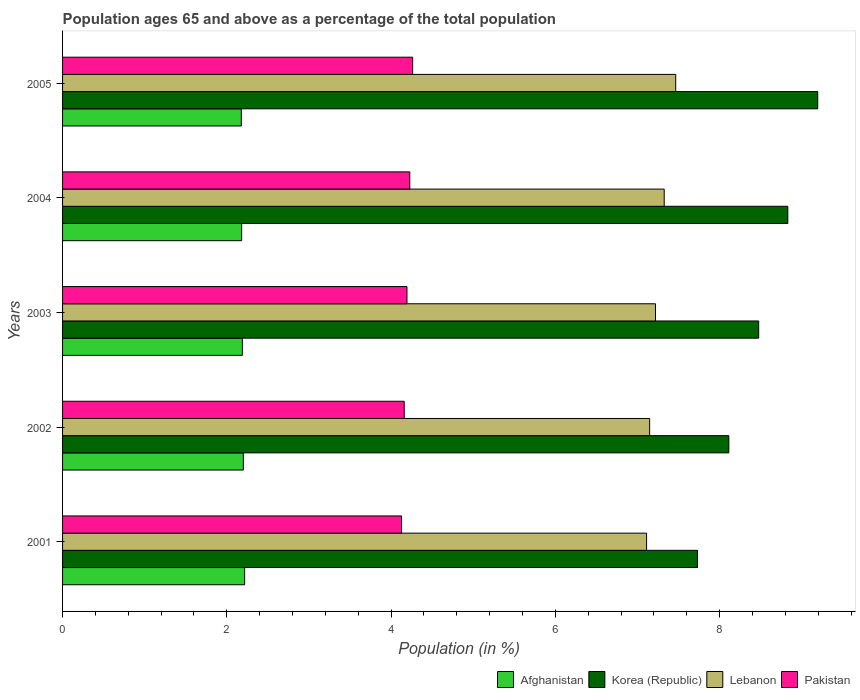How many different coloured bars are there?
Ensure brevity in your answer.  4. How many groups of bars are there?
Give a very brief answer. 5. Are the number of bars per tick equal to the number of legend labels?
Ensure brevity in your answer.  Yes. How many bars are there on the 3rd tick from the top?
Your answer should be very brief. 4. What is the label of the 2nd group of bars from the top?
Provide a short and direct response. 2004. What is the percentage of the population ages 65 and above in Pakistan in 2004?
Ensure brevity in your answer.  4.23. Across all years, what is the maximum percentage of the population ages 65 and above in Afghanistan?
Give a very brief answer. 2.22. Across all years, what is the minimum percentage of the population ages 65 and above in Lebanon?
Give a very brief answer. 7.11. In which year was the percentage of the population ages 65 and above in Lebanon maximum?
Your response must be concise. 2005. What is the total percentage of the population ages 65 and above in Pakistan in the graph?
Provide a succinct answer. 20.97. What is the difference between the percentage of the population ages 65 and above in Korea (Republic) in 2002 and that in 2005?
Provide a short and direct response. -1.08. What is the difference between the percentage of the population ages 65 and above in Lebanon in 2001 and the percentage of the population ages 65 and above in Pakistan in 2003?
Provide a succinct answer. 2.92. What is the average percentage of the population ages 65 and above in Afghanistan per year?
Your answer should be very brief. 2.19. In the year 2002, what is the difference between the percentage of the population ages 65 and above in Lebanon and percentage of the population ages 65 and above in Afghanistan?
Give a very brief answer. 4.95. What is the ratio of the percentage of the population ages 65 and above in Afghanistan in 2002 to that in 2005?
Offer a very short reply. 1.01. Is the difference between the percentage of the population ages 65 and above in Lebanon in 2002 and 2003 greater than the difference between the percentage of the population ages 65 and above in Afghanistan in 2002 and 2003?
Give a very brief answer. No. What is the difference between the highest and the second highest percentage of the population ages 65 and above in Afghanistan?
Ensure brevity in your answer.  0.02. What is the difference between the highest and the lowest percentage of the population ages 65 and above in Lebanon?
Your answer should be very brief. 0.35. What does the 4th bar from the top in 2002 represents?
Offer a very short reply. Afghanistan. What does the 4th bar from the bottom in 2002 represents?
Your answer should be compact. Pakistan. Is it the case that in every year, the sum of the percentage of the population ages 65 and above in Pakistan and percentage of the population ages 65 and above in Korea (Republic) is greater than the percentage of the population ages 65 and above in Lebanon?
Your response must be concise. Yes. How many bars are there?
Keep it short and to the point. 20. Are all the bars in the graph horizontal?
Make the answer very short. Yes. How many years are there in the graph?
Your answer should be compact. 5. Does the graph contain any zero values?
Offer a very short reply. No. Does the graph contain grids?
Keep it short and to the point. No. Where does the legend appear in the graph?
Your response must be concise. Bottom right. How are the legend labels stacked?
Your answer should be very brief. Horizontal. What is the title of the graph?
Your answer should be compact. Population ages 65 and above as a percentage of the total population. What is the label or title of the Y-axis?
Keep it short and to the point. Years. What is the Population (in %) of Afghanistan in 2001?
Offer a very short reply. 2.22. What is the Population (in %) in Korea (Republic) in 2001?
Offer a terse response. 7.73. What is the Population (in %) in Lebanon in 2001?
Give a very brief answer. 7.11. What is the Population (in %) in Pakistan in 2001?
Make the answer very short. 4.13. What is the Population (in %) of Afghanistan in 2002?
Ensure brevity in your answer.  2.2. What is the Population (in %) of Korea (Republic) in 2002?
Make the answer very short. 8.11. What is the Population (in %) of Lebanon in 2002?
Give a very brief answer. 7.15. What is the Population (in %) of Pakistan in 2002?
Give a very brief answer. 4.16. What is the Population (in %) of Afghanistan in 2003?
Make the answer very short. 2.19. What is the Population (in %) of Korea (Republic) in 2003?
Make the answer very short. 8.48. What is the Population (in %) of Lebanon in 2003?
Your answer should be very brief. 7.22. What is the Population (in %) of Pakistan in 2003?
Offer a terse response. 4.19. What is the Population (in %) in Afghanistan in 2004?
Make the answer very short. 2.18. What is the Population (in %) of Korea (Republic) in 2004?
Keep it short and to the point. 8.83. What is the Population (in %) of Lebanon in 2004?
Provide a short and direct response. 7.32. What is the Population (in %) of Pakistan in 2004?
Offer a very short reply. 4.23. What is the Population (in %) of Afghanistan in 2005?
Ensure brevity in your answer.  2.18. What is the Population (in %) of Korea (Republic) in 2005?
Keep it short and to the point. 9.19. What is the Population (in %) in Lebanon in 2005?
Ensure brevity in your answer.  7.47. What is the Population (in %) of Pakistan in 2005?
Your response must be concise. 4.26. Across all years, what is the maximum Population (in %) in Afghanistan?
Offer a terse response. 2.22. Across all years, what is the maximum Population (in %) of Korea (Republic)?
Provide a succinct answer. 9.19. Across all years, what is the maximum Population (in %) in Lebanon?
Your answer should be very brief. 7.47. Across all years, what is the maximum Population (in %) of Pakistan?
Keep it short and to the point. 4.26. Across all years, what is the minimum Population (in %) of Afghanistan?
Keep it short and to the point. 2.18. Across all years, what is the minimum Population (in %) of Korea (Republic)?
Your answer should be compact. 7.73. Across all years, what is the minimum Population (in %) of Lebanon?
Offer a very short reply. 7.11. Across all years, what is the minimum Population (in %) of Pakistan?
Your answer should be very brief. 4.13. What is the total Population (in %) in Afghanistan in the graph?
Provide a succinct answer. 10.96. What is the total Population (in %) of Korea (Republic) in the graph?
Your response must be concise. 42.34. What is the total Population (in %) of Lebanon in the graph?
Ensure brevity in your answer.  36.27. What is the total Population (in %) of Pakistan in the graph?
Keep it short and to the point. 20.97. What is the difference between the Population (in %) in Afghanistan in 2001 and that in 2002?
Your answer should be very brief. 0.02. What is the difference between the Population (in %) of Korea (Republic) in 2001 and that in 2002?
Your response must be concise. -0.38. What is the difference between the Population (in %) of Lebanon in 2001 and that in 2002?
Your answer should be very brief. -0.04. What is the difference between the Population (in %) of Pakistan in 2001 and that in 2002?
Provide a succinct answer. -0.03. What is the difference between the Population (in %) in Afghanistan in 2001 and that in 2003?
Offer a very short reply. 0.03. What is the difference between the Population (in %) of Korea (Republic) in 2001 and that in 2003?
Ensure brevity in your answer.  -0.74. What is the difference between the Population (in %) of Lebanon in 2001 and that in 2003?
Make the answer very short. -0.11. What is the difference between the Population (in %) of Pakistan in 2001 and that in 2003?
Your response must be concise. -0.07. What is the difference between the Population (in %) in Afghanistan in 2001 and that in 2004?
Keep it short and to the point. 0.04. What is the difference between the Population (in %) in Korea (Republic) in 2001 and that in 2004?
Keep it short and to the point. -1.1. What is the difference between the Population (in %) of Lebanon in 2001 and that in 2004?
Make the answer very short. -0.21. What is the difference between the Population (in %) in Pakistan in 2001 and that in 2004?
Your response must be concise. -0.1. What is the difference between the Population (in %) in Afghanistan in 2001 and that in 2005?
Your answer should be very brief. 0.04. What is the difference between the Population (in %) in Korea (Republic) in 2001 and that in 2005?
Offer a very short reply. -1.46. What is the difference between the Population (in %) of Lebanon in 2001 and that in 2005?
Your answer should be very brief. -0.35. What is the difference between the Population (in %) of Pakistan in 2001 and that in 2005?
Provide a short and direct response. -0.13. What is the difference between the Population (in %) in Afghanistan in 2002 and that in 2003?
Make the answer very short. 0.01. What is the difference between the Population (in %) of Korea (Republic) in 2002 and that in 2003?
Keep it short and to the point. -0.36. What is the difference between the Population (in %) in Lebanon in 2002 and that in 2003?
Offer a very short reply. -0.07. What is the difference between the Population (in %) in Pakistan in 2002 and that in 2003?
Keep it short and to the point. -0.03. What is the difference between the Population (in %) of Afghanistan in 2002 and that in 2004?
Keep it short and to the point. 0.02. What is the difference between the Population (in %) in Korea (Republic) in 2002 and that in 2004?
Provide a succinct answer. -0.72. What is the difference between the Population (in %) in Lebanon in 2002 and that in 2004?
Make the answer very short. -0.18. What is the difference between the Population (in %) of Pakistan in 2002 and that in 2004?
Your response must be concise. -0.07. What is the difference between the Population (in %) in Afghanistan in 2002 and that in 2005?
Your answer should be very brief. 0.02. What is the difference between the Population (in %) in Korea (Republic) in 2002 and that in 2005?
Offer a very short reply. -1.08. What is the difference between the Population (in %) in Lebanon in 2002 and that in 2005?
Provide a succinct answer. -0.32. What is the difference between the Population (in %) of Pakistan in 2002 and that in 2005?
Keep it short and to the point. -0.1. What is the difference between the Population (in %) of Afghanistan in 2003 and that in 2004?
Provide a short and direct response. 0.01. What is the difference between the Population (in %) of Korea (Republic) in 2003 and that in 2004?
Offer a terse response. -0.35. What is the difference between the Population (in %) of Lebanon in 2003 and that in 2004?
Provide a short and direct response. -0.11. What is the difference between the Population (in %) in Pakistan in 2003 and that in 2004?
Your answer should be compact. -0.03. What is the difference between the Population (in %) of Afghanistan in 2003 and that in 2005?
Your response must be concise. 0.01. What is the difference between the Population (in %) in Korea (Republic) in 2003 and that in 2005?
Offer a very short reply. -0.72. What is the difference between the Population (in %) of Lebanon in 2003 and that in 2005?
Keep it short and to the point. -0.25. What is the difference between the Population (in %) in Pakistan in 2003 and that in 2005?
Give a very brief answer. -0.07. What is the difference between the Population (in %) of Afghanistan in 2004 and that in 2005?
Your answer should be very brief. 0. What is the difference between the Population (in %) of Korea (Republic) in 2004 and that in 2005?
Give a very brief answer. -0.36. What is the difference between the Population (in %) in Lebanon in 2004 and that in 2005?
Make the answer very short. -0.14. What is the difference between the Population (in %) of Pakistan in 2004 and that in 2005?
Provide a succinct answer. -0.03. What is the difference between the Population (in %) of Afghanistan in 2001 and the Population (in %) of Korea (Republic) in 2002?
Give a very brief answer. -5.9. What is the difference between the Population (in %) in Afghanistan in 2001 and the Population (in %) in Lebanon in 2002?
Offer a terse response. -4.93. What is the difference between the Population (in %) in Afghanistan in 2001 and the Population (in %) in Pakistan in 2002?
Your answer should be compact. -1.94. What is the difference between the Population (in %) in Korea (Republic) in 2001 and the Population (in %) in Lebanon in 2002?
Your answer should be compact. 0.58. What is the difference between the Population (in %) in Korea (Republic) in 2001 and the Population (in %) in Pakistan in 2002?
Offer a very short reply. 3.57. What is the difference between the Population (in %) in Lebanon in 2001 and the Population (in %) in Pakistan in 2002?
Your response must be concise. 2.95. What is the difference between the Population (in %) of Afghanistan in 2001 and the Population (in %) of Korea (Republic) in 2003?
Provide a succinct answer. -6.26. What is the difference between the Population (in %) of Afghanistan in 2001 and the Population (in %) of Lebanon in 2003?
Offer a terse response. -5. What is the difference between the Population (in %) in Afghanistan in 2001 and the Population (in %) in Pakistan in 2003?
Ensure brevity in your answer.  -1.98. What is the difference between the Population (in %) in Korea (Republic) in 2001 and the Population (in %) in Lebanon in 2003?
Provide a succinct answer. 0.51. What is the difference between the Population (in %) in Korea (Republic) in 2001 and the Population (in %) in Pakistan in 2003?
Provide a short and direct response. 3.54. What is the difference between the Population (in %) of Lebanon in 2001 and the Population (in %) of Pakistan in 2003?
Provide a succinct answer. 2.92. What is the difference between the Population (in %) in Afghanistan in 2001 and the Population (in %) in Korea (Republic) in 2004?
Offer a very short reply. -6.61. What is the difference between the Population (in %) of Afghanistan in 2001 and the Population (in %) of Lebanon in 2004?
Offer a very short reply. -5.11. What is the difference between the Population (in %) of Afghanistan in 2001 and the Population (in %) of Pakistan in 2004?
Provide a succinct answer. -2.01. What is the difference between the Population (in %) of Korea (Republic) in 2001 and the Population (in %) of Lebanon in 2004?
Ensure brevity in your answer.  0.41. What is the difference between the Population (in %) in Korea (Republic) in 2001 and the Population (in %) in Pakistan in 2004?
Ensure brevity in your answer.  3.5. What is the difference between the Population (in %) of Lebanon in 2001 and the Population (in %) of Pakistan in 2004?
Your response must be concise. 2.88. What is the difference between the Population (in %) in Afghanistan in 2001 and the Population (in %) in Korea (Republic) in 2005?
Provide a short and direct response. -6.98. What is the difference between the Population (in %) in Afghanistan in 2001 and the Population (in %) in Lebanon in 2005?
Offer a terse response. -5.25. What is the difference between the Population (in %) of Afghanistan in 2001 and the Population (in %) of Pakistan in 2005?
Ensure brevity in your answer.  -2.05. What is the difference between the Population (in %) of Korea (Republic) in 2001 and the Population (in %) of Lebanon in 2005?
Offer a very short reply. 0.27. What is the difference between the Population (in %) of Korea (Republic) in 2001 and the Population (in %) of Pakistan in 2005?
Keep it short and to the point. 3.47. What is the difference between the Population (in %) of Lebanon in 2001 and the Population (in %) of Pakistan in 2005?
Your answer should be compact. 2.85. What is the difference between the Population (in %) of Afghanistan in 2002 and the Population (in %) of Korea (Republic) in 2003?
Offer a very short reply. -6.27. What is the difference between the Population (in %) in Afghanistan in 2002 and the Population (in %) in Lebanon in 2003?
Keep it short and to the point. -5.02. What is the difference between the Population (in %) of Afghanistan in 2002 and the Population (in %) of Pakistan in 2003?
Keep it short and to the point. -1.99. What is the difference between the Population (in %) in Korea (Republic) in 2002 and the Population (in %) in Lebanon in 2003?
Provide a succinct answer. 0.89. What is the difference between the Population (in %) of Korea (Republic) in 2002 and the Population (in %) of Pakistan in 2003?
Your response must be concise. 3.92. What is the difference between the Population (in %) in Lebanon in 2002 and the Population (in %) in Pakistan in 2003?
Keep it short and to the point. 2.95. What is the difference between the Population (in %) in Afghanistan in 2002 and the Population (in %) in Korea (Republic) in 2004?
Provide a succinct answer. -6.63. What is the difference between the Population (in %) in Afghanistan in 2002 and the Population (in %) in Lebanon in 2004?
Ensure brevity in your answer.  -5.12. What is the difference between the Population (in %) in Afghanistan in 2002 and the Population (in %) in Pakistan in 2004?
Give a very brief answer. -2.03. What is the difference between the Population (in %) in Korea (Republic) in 2002 and the Population (in %) in Lebanon in 2004?
Give a very brief answer. 0.79. What is the difference between the Population (in %) in Korea (Republic) in 2002 and the Population (in %) in Pakistan in 2004?
Your answer should be compact. 3.88. What is the difference between the Population (in %) of Lebanon in 2002 and the Population (in %) of Pakistan in 2004?
Provide a succinct answer. 2.92. What is the difference between the Population (in %) of Afghanistan in 2002 and the Population (in %) of Korea (Republic) in 2005?
Your response must be concise. -6.99. What is the difference between the Population (in %) in Afghanistan in 2002 and the Population (in %) in Lebanon in 2005?
Keep it short and to the point. -5.26. What is the difference between the Population (in %) of Afghanistan in 2002 and the Population (in %) of Pakistan in 2005?
Offer a very short reply. -2.06. What is the difference between the Population (in %) in Korea (Republic) in 2002 and the Population (in %) in Lebanon in 2005?
Your answer should be very brief. 0.65. What is the difference between the Population (in %) in Korea (Republic) in 2002 and the Population (in %) in Pakistan in 2005?
Your response must be concise. 3.85. What is the difference between the Population (in %) in Lebanon in 2002 and the Population (in %) in Pakistan in 2005?
Give a very brief answer. 2.89. What is the difference between the Population (in %) in Afghanistan in 2003 and the Population (in %) in Korea (Republic) in 2004?
Offer a very short reply. -6.64. What is the difference between the Population (in %) of Afghanistan in 2003 and the Population (in %) of Lebanon in 2004?
Offer a very short reply. -5.14. What is the difference between the Population (in %) in Afghanistan in 2003 and the Population (in %) in Pakistan in 2004?
Offer a terse response. -2.04. What is the difference between the Population (in %) in Korea (Republic) in 2003 and the Population (in %) in Lebanon in 2004?
Give a very brief answer. 1.15. What is the difference between the Population (in %) of Korea (Republic) in 2003 and the Population (in %) of Pakistan in 2004?
Keep it short and to the point. 4.25. What is the difference between the Population (in %) of Lebanon in 2003 and the Population (in %) of Pakistan in 2004?
Offer a terse response. 2.99. What is the difference between the Population (in %) of Afghanistan in 2003 and the Population (in %) of Korea (Republic) in 2005?
Make the answer very short. -7.01. What is the difference between the Population (in %) in Afghanistan in 2003 and the Population (in %) in Lebanon in 2005?
Your answer should be compact. -5.28. What is the difference between the Population (in %) in Afghanistan in 2003 and the Population (in %) in Pakistan in 2005?
Your answer should be very brief. -2.07. What is the difference between the Population (in %) of Korea (Republic) in 2003 and the Population (in %) of Lebanon in 2005?
Your answer should be very brief. 1.01. What is the difference between the Population (in %) of Korea (Republic) in 2003 and the Population (in %) of Pakistan in 2005?
Keep it short and to the point. 4.21. What is the difference between the Population (in %) in Lebanon in 2003 and the Population (in %) in Pakistan in 2005?
Provide a succinct answer. 2.96. What is the difference between the Population (in %) of Afghanistan in 2004 and the Population (in %) of Korea (Republic) in 2005?
Your response must be concise. -7.01. What is the difference between the Population (in %) in Afghanistan in 2004 and the Population (in %) in Lebanon in 2005?
Your answer should be very brief. -5.28. What is the difference between the Population (in %) of Afghanistan in 2004 and the Population (in %) of Pakistan in 2005?
Your response must be concise. -2.08. What is the difference between the Population (in %) in Korea (Republic) in 2004 and the Population (in %) in Lebanon in 2005?
Give a very brief answer. 1.36. What is the difference between the Population (in %) in Korea (Republic) in 2004 and the Population (in %) in Pakistan in 2005?
Provide a succinct answer. 4.57. What is the difference between the Population (in %) of Lebanon in 2004 and the Population (in %) of Pakistan in 2005?
Your answer should be very brief. 3.06. What is the average Population (in %) in Afghanistan per year?
Offer a terse response. 2.19. What is the average Population (in %) in Korea (Republic) per year?
Your response must be concise. 8.47. What is the average Population (in %) in Lebanon per year?
Provide a succinct answer. 7.25. What is the average Population (in %) in Pakistan per year?
Offer a terse response. 4.19. In the year 2001, what is the difference between the Population (in %) of Afghanistan and Population (in %) of Korea (Republic)?
Make the answer very short. -5.51. In the year 2001, what is the difference between the Population (in %) of Afghanistan and Population (in %) of Lebanon?
Provide a short and direct response. -4.89. In the year 2001, what is the difference between the Population (in %) in Afghanistan and Population (in %) in Pakistan?
Offer a terse response. -1.91. In the year 2001, what is the difference between the Population (in %) of Korea (Republic) and Population (in %) of Lebanon?
Offer a very short reply. 0.62. In the year 2001, what is the difference between the Population (in %) of Korea (Republic) and Population (in %) of Pakistan?
Your response must be concise. 3.6. In the year 2001, what is the difference between the Population (in %) of Lebanon and Population (in %) of Pakistan?
Offer a terse response. 2.98. In the year 2002, what is the difference between the Population (in %) of Afghanistan and Population (in %) of Korea (Republic)?
Provide a succinct answer. -5.91. In the year 2002, what is the difference between the Population (in %) of Afghanistan and Population (in %) of Lebanon?
Provide a succinct answer. -4.95. In the year 2002, what is the difference between the Population (in %) of Afghanistan and Population (in %) of Pakistan?
Ensure brevity in your answer.  -1.96. In the year 2002, what is the difference between the Population (in %) of Korea (Republic) and Population (in %) of Lebanon?
Your response must be concise. 0.96. In the year 2002, what is the difference between the Population (in %) of Korea (Republic) and Population (in %) of Pakistan?
Provide a short and direct response. 3.95. In the year 2002, what is the difference between the Population (in %) of Lebanon and Population (in %) of Pakistan?
Provide a short and direct response. 2.99. In the year 2003, what is the difference between the Population (in %) of Afghanistan and Population (in %) of Korea (Republic)?
Provide a succinct answer. -6.29. In the year 2003, what is the difference between the Population (in %) in Afghanistan and Population (in %) in Lebanon?
Provide a short and direct response. -5.03. In the year 2003, what is the difference between the Population (in %) in Afghanistan and Population (in %) in Pakistan?
Your answer should be compact. -2. In the year 2003, what is the difference between the Population (in %) of Korea (Republic) and Population (in %) of Lebanon?
Provide a short and direct response. 1.26. In the year 2003, what is the difference between the Population (in %) of Korea (Republic) and Population (in %) of Pakistan?
Your response must be concise. 4.28. In the year 2003, what is the difference between the Population (in %) of Lebanon and Population (in %) of Pakistan?
Offer a terse response. 3.03. In the year 2004, what is the difference between the Population (in %) in Afghanistan and Population (in %) in Korea (Republic)?
Your response must be concise. -6.65. In the year 2004, what is the difference between the Population (in %) in Afghanistan and Population (in %) in Lebanon?
Make the answer very short. -5.14. In the year 2004, what is the difference between the Population (in %) of Afghanistan and Population (in %) of Pakistan?
Offer a terse response. -2.05. In the year 2004, what is the difference between the Population (in %) of Korea (Republic) and Population (in %) of Lebanon?
Give a very brief answer. 1.5. In the year 2004, what is the difference between the Population (in %) of Korea (Republic) and Population (in %) of Pakistan?
Your answer should be compact. 4.6. In the year 2004, what is the difference between the Population (in %) of Lebanon and Population (in %) of Pakistan?
Your answer should be very brief. 3.1. In the year 2005, what is the difference between the Population (in %) in Afghanistan and Population (in %) in Korea (Republic)?
Offer a terse response. -7.02. In the year 2005, what is the difference between the Population (in %) of Afghanistan and Population (in %) of Lebanon?
Give a very brief answer. -5.29. In the year 2005, what is the difference between the Population (in %) of Afghanistan and Population (in %) of Pakistan?
Provide a short and direct response. -2.09. In the year 2005, what is the difference between the Population (in %) in Korea (Republic) and Population (in %) in Lebanon?
Ensure brevity in your answer.  1.73. In the year 2005, what is the difference between the Population (in %) in Korea (Republic) and Population (in %) in Pakistan?
Offer a very short reply. 4.93. In the year 2005, what is the difference between the Population (in %) in Lebanon and Population (in %) in Pakistan?
Keep it short and to the point. 3.2. What is the ratio of the Population (in %) in Afghanistan in 2001 to that in 2002?
Ensure brevity in your answer.  1.01. What is the ratio of the Population (in %) of Korea (Republic) in 2001 to that in 2002?
Your answer should be very brief. 0.95. What is the ratio of the Population (in %) in Afghanistan in 2001 to that in 2003?
Ensure brevity in your answer.  1.01. What is the ratio of the Population (in %) of Korea (Republic) in 2001 to that in 2003?
Your response must be concise. 0.91. What is the ratio of the Population (in %) of Lebanon in 2001 to that in 2003?
Make the answer very short. 0.98. What is the ratio of the Population (in %) in Pakistan in 2001 to that in 2003?
Provide a succinct answer. 0.98. What is the ratio of the Population (in %) in Afghanistan in 2001 to that in 2004?
Offer a very short reply. 1.02. What is the ratio of the Population (in %) of Korea (Republic) in 2001 to that in 2004?
Your response must be concise. 0.88. What is the ratio of the Population (in %) in Lebanon in 2001 to that in 2004?
Offer a very short reply. 0.97. What is the ratio of the Population (in %) in Pakistan in 2001 to that in 2004?
Ensure brevity in your answer.  0.98. What is the ratio of the Population (in %) of Afghanistan in 2001 to that in 2005?
Your answer should be very brief. 1.02. What is the ratio of the Population (in %) in Korea (Republic) in 2001 to that in 2005?
Provide a succinct answer. 0.84. What is the ratio of the Population (in %) of Lebanon in 2001 to that in 2005?
Offer a very short reply. 0.95. What is the ratio of the Population (in %) in Pakistan in 2001 to that in 2005?
Make the answer very short. 0.97. What is the ratio of the Population (in %) of Afghanistan in 2002 to that in 2003?
Provide a short and direct response. 1.01. What is the ratio of the Population (in %) in Korea (Republic) in 2002 to that in 2003?
Your answer should be compact. 0.96. What is the ratio of the Population (in %) of Lebanon in 2002 to that in 2003?
Give a very brief answer. 0.99. What is the ratio of the Population (in %) in Pakistan in 2002 to that in 2003?
Provide a succinct answer. 0.99. What is the ratio of the Population (in %) in Afghanistan in 2002 to that in 2004?
Your answer should be compact. 1.01. What is the ratio of the Population (in %) of Korea (Republic) in 2002 to that in 2004?
Provide a succinct answer. 0.92. What is the ratio of the Population (in %) of Lebanon in 2002 to that in 2004?
Provide a succinct answer. 0.98. What is the ratio of the Population (in %) of Pakistan in 2002 to that in 2004?
Provide a short and direct response. 0.98. What is the ratio of the Population (in %) in Afghanistan in 2002 to that in 2005?
Give a very brief answer. 1.01. What is the ratio of the Population (in %) of Korea (Republic) in 2002 to that in 2005?
Ensure brevity in your answer.  0.88. What is the ratio of the Population (in %) in Lebanon in 2002 to that in 2005?
Your answer should be very brief. 0.96. What is the ratio of the Population (in %) in Pakistan in 2002 to that in 2005?
Your answer should be compact. 0.98. What is the ratio of the Population (in %) in Afghanistan in 2003 to that in 2004?
Keep it short and to the point. 1. What is the ratio of the Population (in %) of Korea (Republic) in 2003 to that in 2004?
Keep it short and to the point. 0.96. What is the ratio of the Population (in %) in Lebanon in 2003 to that in 2004?
Provide a short and direct response. 0.99. What is the ratio of the Population (in %) in Afghanistan in 2003 to that in 2005?
Make the answer very short. 1.01. What is the ratio of the Population (in %) of Korea (Republic) in 2003 to that in 2005?
Keep it short and to the point. 0.92. What is the ratio of the Population (in %) in Pakistan in 2003 to that in 2005?
Provide a short and direct response. 0.98. What is the ratio of the Population (in %) of Korea (Republic) in 2004 to that in 2005?
Make the answer very short. 0.96. What is the ratio of the Population (in %) of Lebanon in 2004 to that in 2005?
Ensure brevity in your answer.  0.98. What is the ratio of the Population (in %) of Pakistan in 2004 to that in 2005?
Offer a terse response. 0.99. What is the difference between the highest and the second highest Population (in %) of Afghanistan?
Give a very brief answer. 0.02. What is the difference between the highest and the second highest Population (in %) of Korea (Republic)?
Give a very brief answer. 0.36. What is the difference between the highest and the second highest Population (in %) of Lebanon?
Offer a very short reply. 0.14. What is the difference between the highest and the second highest Population (in %) in Pakistan?
Give a very brief answer. 0.03. What is the difference between the highest and the lowest Population (in %) of Afghanistan?
Provide a succinct answer. 0.04. What is the difference between the highest and the lowest Population (in %) in Korea (Republic)?
Offer a terse response. 1.46. What is the difference between the highest and the lowest Population (in %) in Lebanon?
Make the answer very short. 0.35. What is the difference between the highest and the lowest Population (in %) in Pakistan?
Make the answer very short. 0.13. 